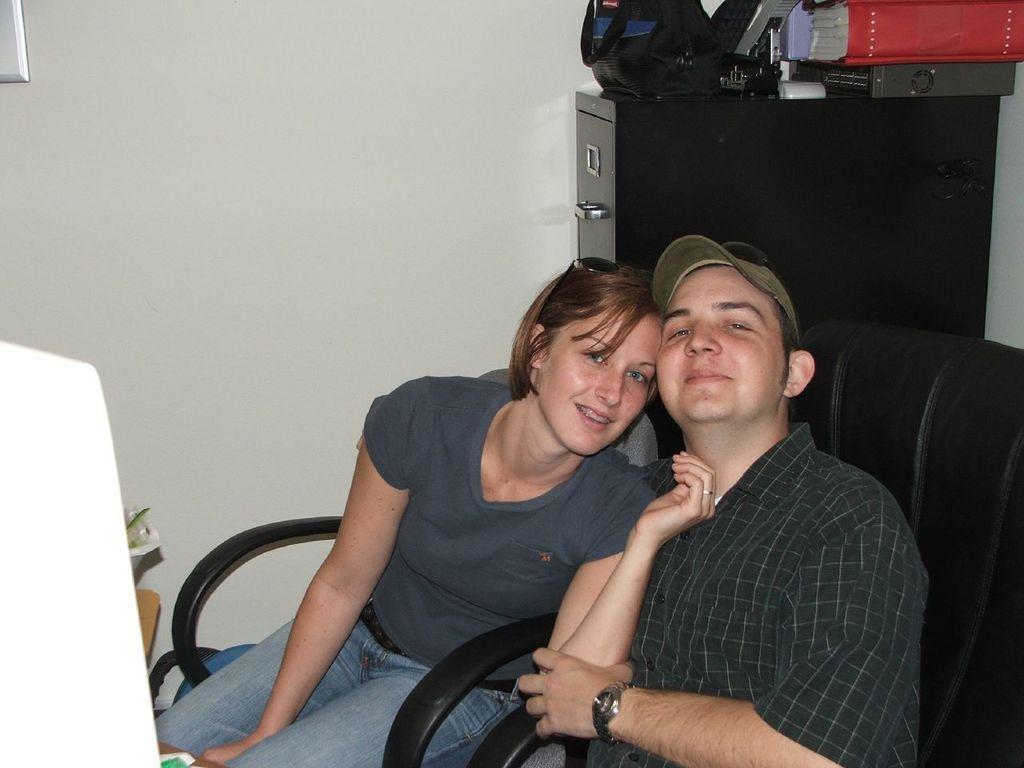How would you summarize this image in a sentence or two? In the image we can see there are two people sitting on the chair and there is a table at the back on which there are books and bags are kept. Behind there is a wall which is white colour. 